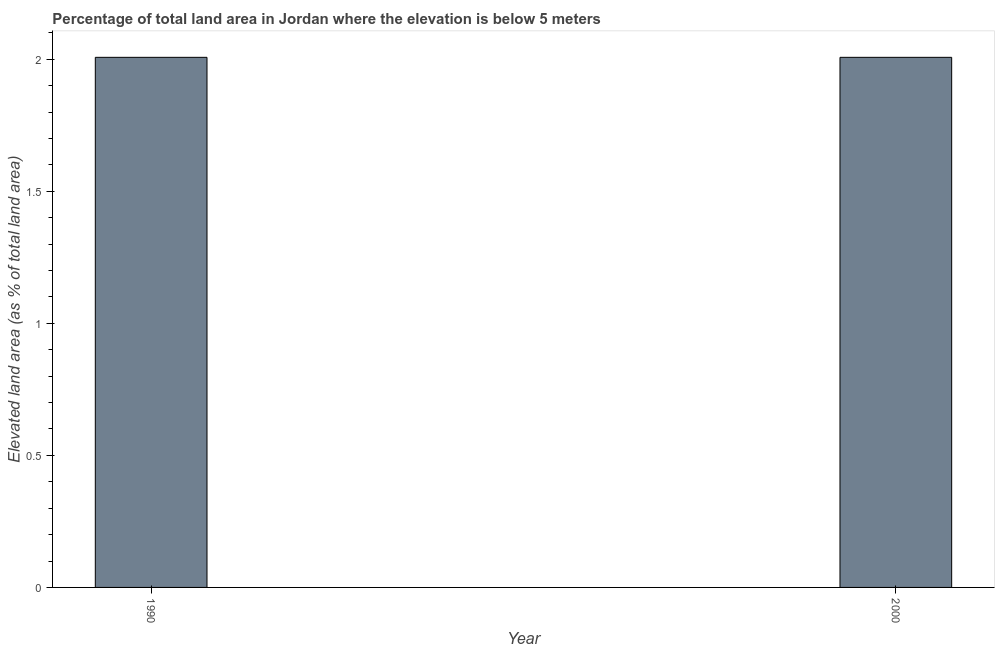Does the graph contain any zero values?
Offer a terse response. No. What is the title of the graph?
Provide a short and direct response. Percentage of total land area in Jordan where the elevation is below 5 meters. What is the label or title of the X-axis?
Offer a terse response. Year. What is the label or title of the Y-axis?
Keep it short and to the point. Elevated land area (as % of total land area). What is the total elevated land area in 1990?
Offer a terse response. 2.01. Across all years, what is the maximum total elevated land area?
Keep it short and to the point. 2.01. Across all years, what is the minimum total elevated land area?
Keep it short and to the point. 2.01. In which year was the total elevated land area minimum?
Your response must be concise. 1990. What is the sum of the total elevated land area?
Offer a very short reply. 4.02. What is the difference between the total elevated land area in 1990 and 2000?
Your response must be concise. 0. What is the average total elevated land area per year?
Offer a terse response. 2.01. What is the median total elevated land area?
Provide a succinct answer. 2.01. In how many years, is the total elevated land area greater than 1.1 %?
Offer a terse response. 2. Do a majority of the years between 1990 and 2000 (inclusive) have total elevated land area greater than 1.5 %?
Provide a succinct answer. Yes. In how many years, is the total elevated land area greater than the average total elevated land area taken over all years?
Offer a very short reply. 0. How many bars are there?
Your answer should be compact. 2. How many years are there in the graph?
Offer a terse response. 2. What is the Elevated land area (as % of total land area) of 1990?
Your answer should be very brief. 2.01. What is the Elevated land area (as % of total land area) of 2000?
Your answer should be very brief. 2.01. What is the difference between the Elevated land area (as % of total land area) in 1990 and 2000?
Your answer should be very brief. 0. What is the ratio of the Elevated land area (as % of total land area) in 1990 to that in 2000?
Offer a very short reply. 1. 